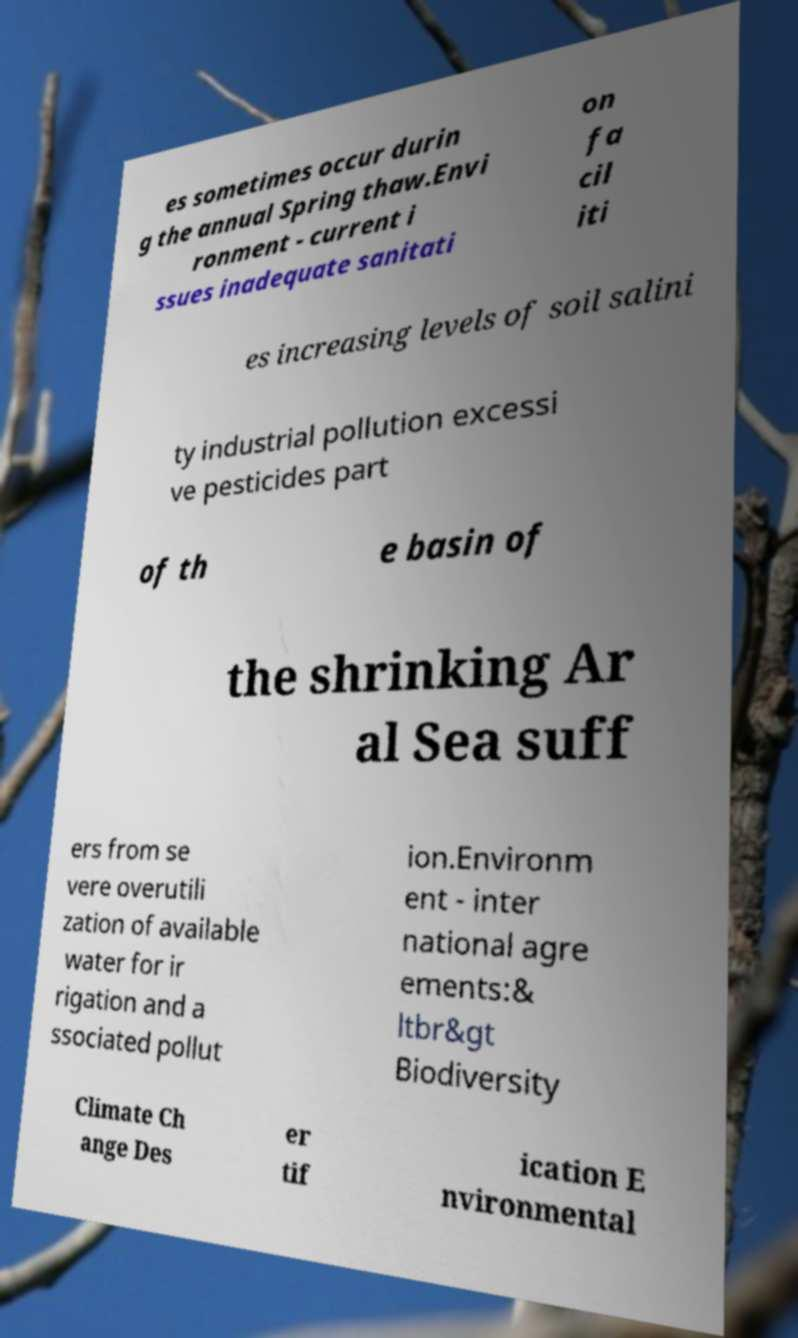There's text embedded in this image that I need extracted. Can you transcribe it verbatim? es sometimes occur durin g the annual Spring thaw.Envi ronment - current i ssues inadequate sanitati on fa cil iti es increasing levels of soil salini ty industrial pollution excessi ve pesticides part of th e basin of the shrinking Ar al Sea suff ers from se vere overutili zation of available water for ir rigation and a ssociated pollut ion.Environm ent - inter national agre ements:& ltbr&gt Biodiversity Climate Ch ange Des er tif ication E nvironmental 